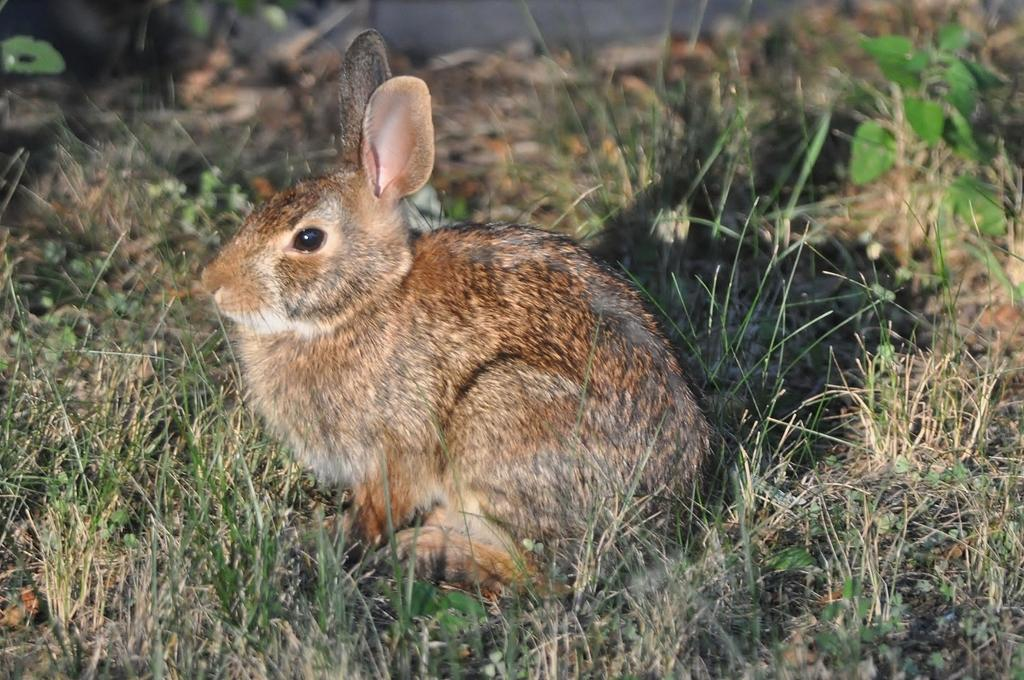What type of animal is in the picture? There is a rabbit in the picture. What other living organism can be seen in the picture? There is a plant in the picture. What is the ground covered with in the picture? There is grass on the ground in the picture. What type of wrench is being used to water the plant in the picture? There is no wrench present in the picture, and the plant does not appear to be watered. 